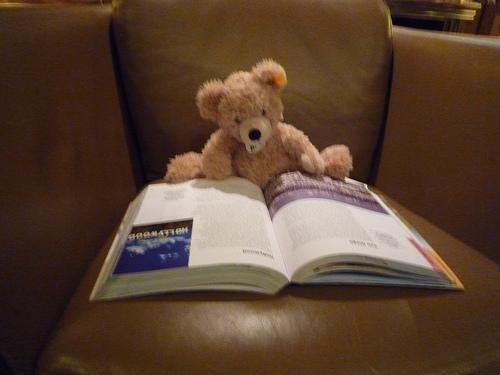How many books are in the picture?
Give a very brief answer. 1. 